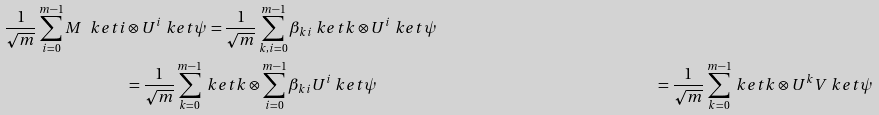Convert formula to latex. <formula><loc_0><loc_0><loc_500><loc_500>\frac { 1 } { \sqrt { m } } \sum _ { i = 0 } ^ { m - 1 } M \ k e t { i } & \otimes U ^ { i } \ k e t { \psi } = \frac { 1 } { \sqrt { m } } \sum _ { k , i = 0 } ^ { m - 1 } \beta _ { k i } \ k e t { k } \otimes U ^ { i } \ k e t { \psi } \\ & = \frac { 1 } { \sqrt { m } } \sum _ { k = 0 } ^ { m - 1 } \ k e t { k } \otimes \sum _ { i = 0 } ^ { m - 1 } \beta _ { k i } U ^ { i } \ k e t { \psi } & = \frac { 1 } { \sqrt { m } } \sum _ { k = 0 } ^ { m - 1 } \ k e t { k } \otimes U ^ { k } V \ k e t { \psi }</formula> 